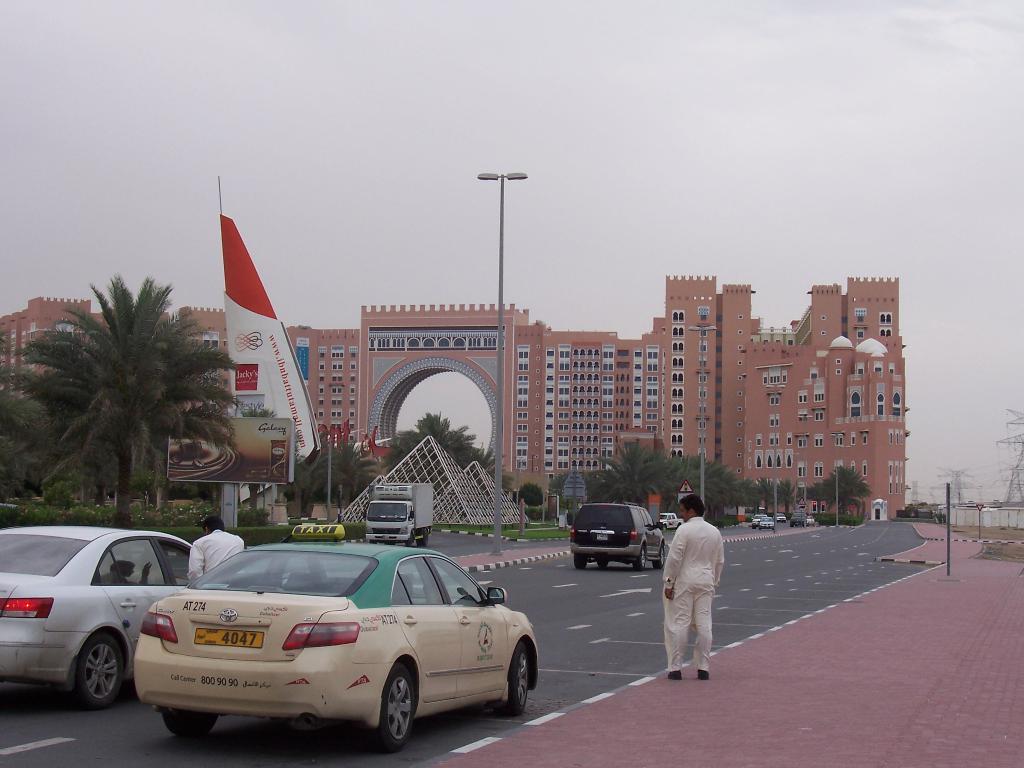What's the yellow licnse plate?
Provide a short and direct response. 4047. What is the brand of the car?
Provide a short and direct response. Toyota. 